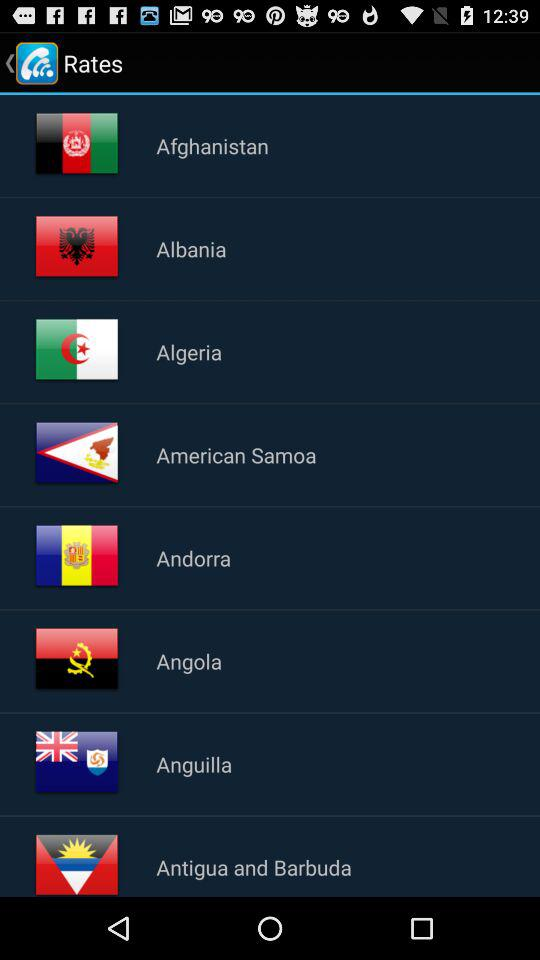What is the application name? The application name is "WiCall". 